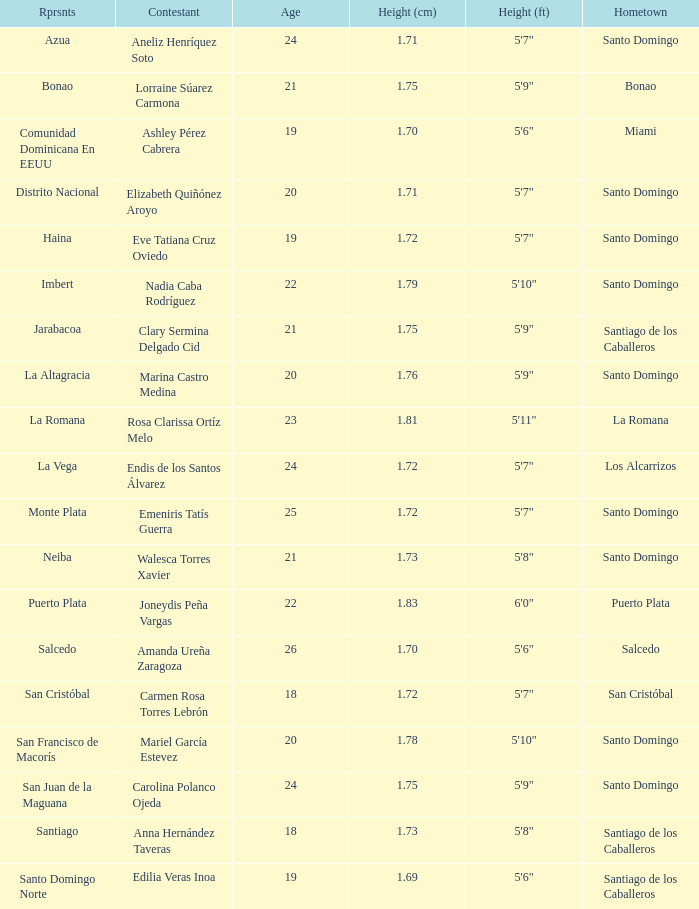Name the represents for los alcarrizos La Vega. Could you help me parse every detail presented in this table? {'header': ['Rprsnts', 'Contestant', 'Age', 'Height (cm)', 'Height (ft)', 'Hometown'], 'rows': [['Azua', 'Aneliz Henríquez Soto', '24', '1.71', '5\'7"', 'Santo Domingo'], ['Bonao', 'Lorraine Súarez Carmona', '21', '1.75', '5\'9"', 'Bonao'], ['Comunidad Dominicana En EEUU', 'Ashley Pérez Cabrera', '19', '1.70', '5\'6"', 'Miami'], ['Distrito Nacional', 'Elizabeth Quiñónez Aroyo', '20', '1.71', '5\'7"', 'Santo Domingo'], ['Haina', 'Eve Tatiana Cruz Oviedo', '19', '1.72', '5\'7"', 'Santo Domingo'], ['Imbert', 'Nadia Caba Rodríguez', '22', '1.79', '5\'10"', 'Santo Domingo'], ['Jarabacoa', 'Clary Sermina Delgado Cid', '21', '1.75', '5\'9"', 'Santiago de los Caballeros'], ['La Altagracia', 'Marina Castro Medina', '20', '1.76', '5\'9"', 'Santo Domingo'], ['La Romana', 'Rosa Clarissa Ortíz Melo', '23', '1.81', '5\'11"', 'La Romana'], ['La Vega', 'Endis de los Santos Álvarez', '24', '1.72', '5\'7"', 'Los Alcarrizos'], ['Monte Plata', 'Emeniris Tatís Guerra', '25', '1.72', '5\'7"', 'Santo Domingo'], ['Neiba', 'Walesca Torres Xavier', '21', '1.73', '5\'8"', 'Santo Domingo'], ['Puerto Plata', 'Joneydis Peña Vargas', '22', '1.83', '6\'0"', 'Puerto Plata'], ['Salcedo', 'Amanda Ureña Zaragoza', '26', '1.70', '5\'6"', 'Salcedo'], ['San Cristóbal', 'Carmen Rosa Torres Lebrón', '18', '1.72', '5\'7"', 'San Cristóbal'], ['San Francisco de Macorís', 'Mariel García Estevez', '20', '1.78', '5\'10"', 'Santo Domingo'], ['San Juan de la Maguana', 'Carolina Polanco Ojeda', '24', '1.75', '5\'9"', 'Santo Domingo'], ['Santiago', 'Anna Hernández Taveras', '18', '1.73', '5\'8"', 'Santiago de los Caballeros'], ['Santo Domingo Norte', 'Edilia Veras Inoa', '19', '1.69', '5\'6"', 'Santiago de los Caballeros']]} 